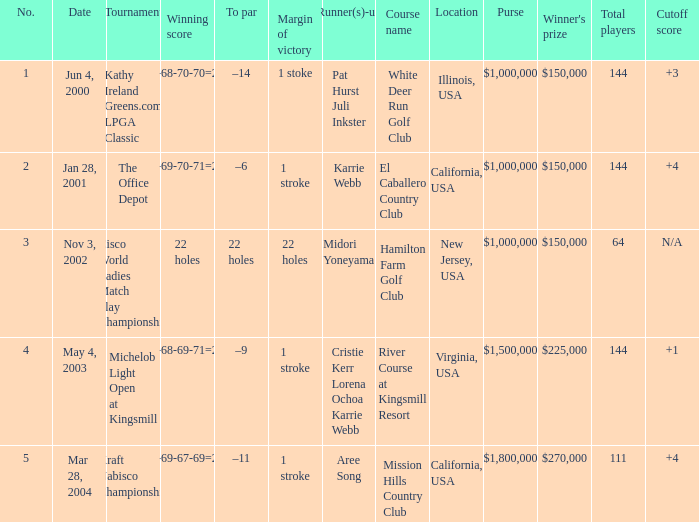Where is the margin of victory dated mar 28, 2004? 1 stroke. 